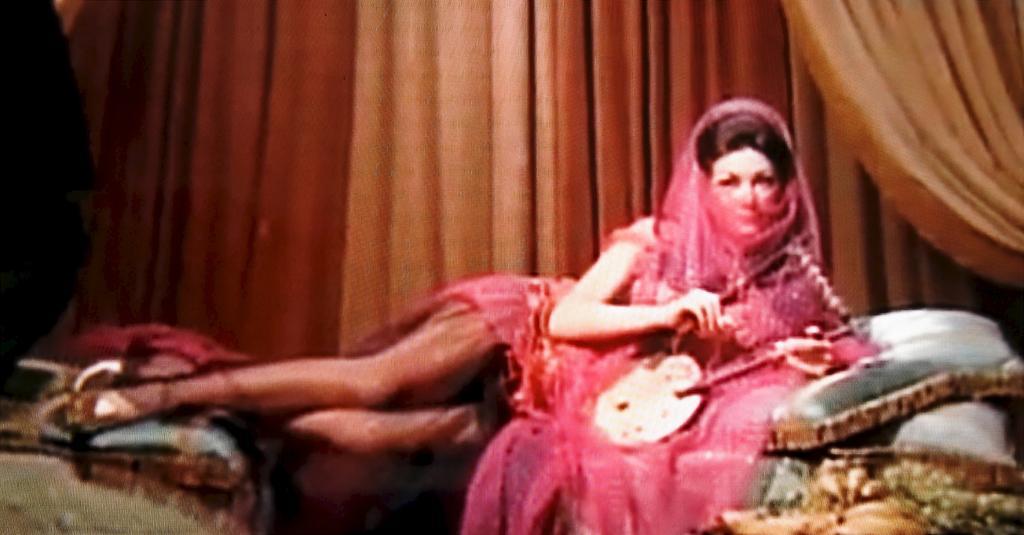Describe this image in one or two sentences. In this picture we can see two people where a woman sitting, pillows and at the back of them we can see curtains. 